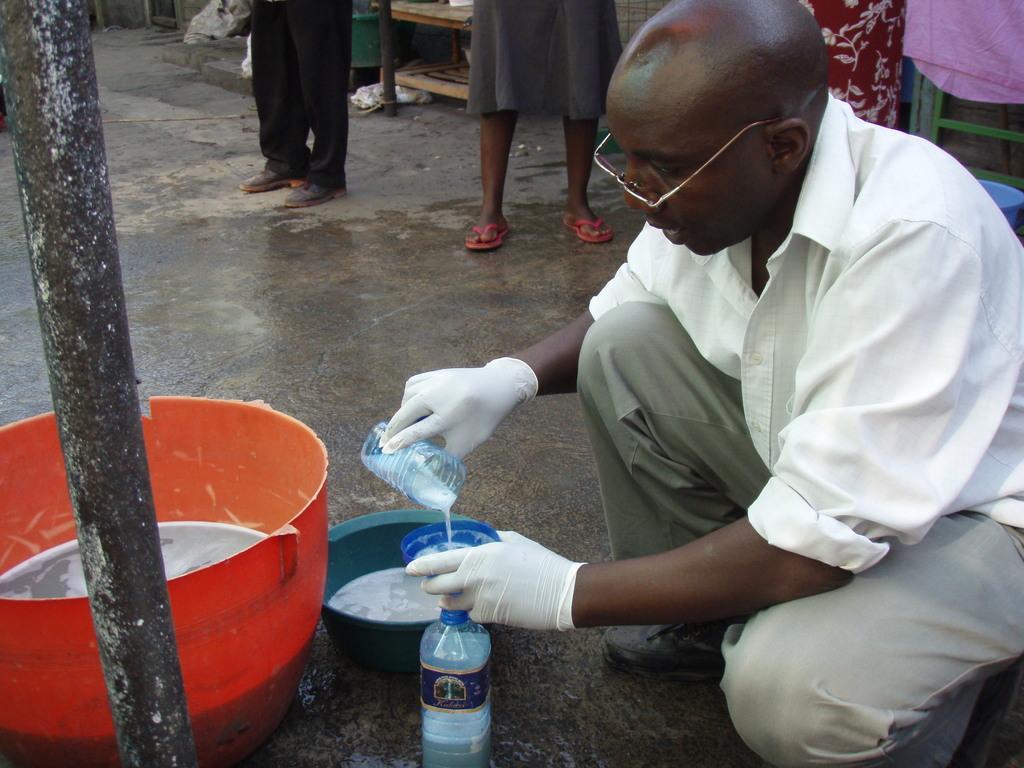Describe this image in one or two sentences. In this image I can see person holding something. We can see bottle and tubs. He is wearing white color gloves and white and ash color dress. Back Side I can see few people standing and some objects are on the floor. 